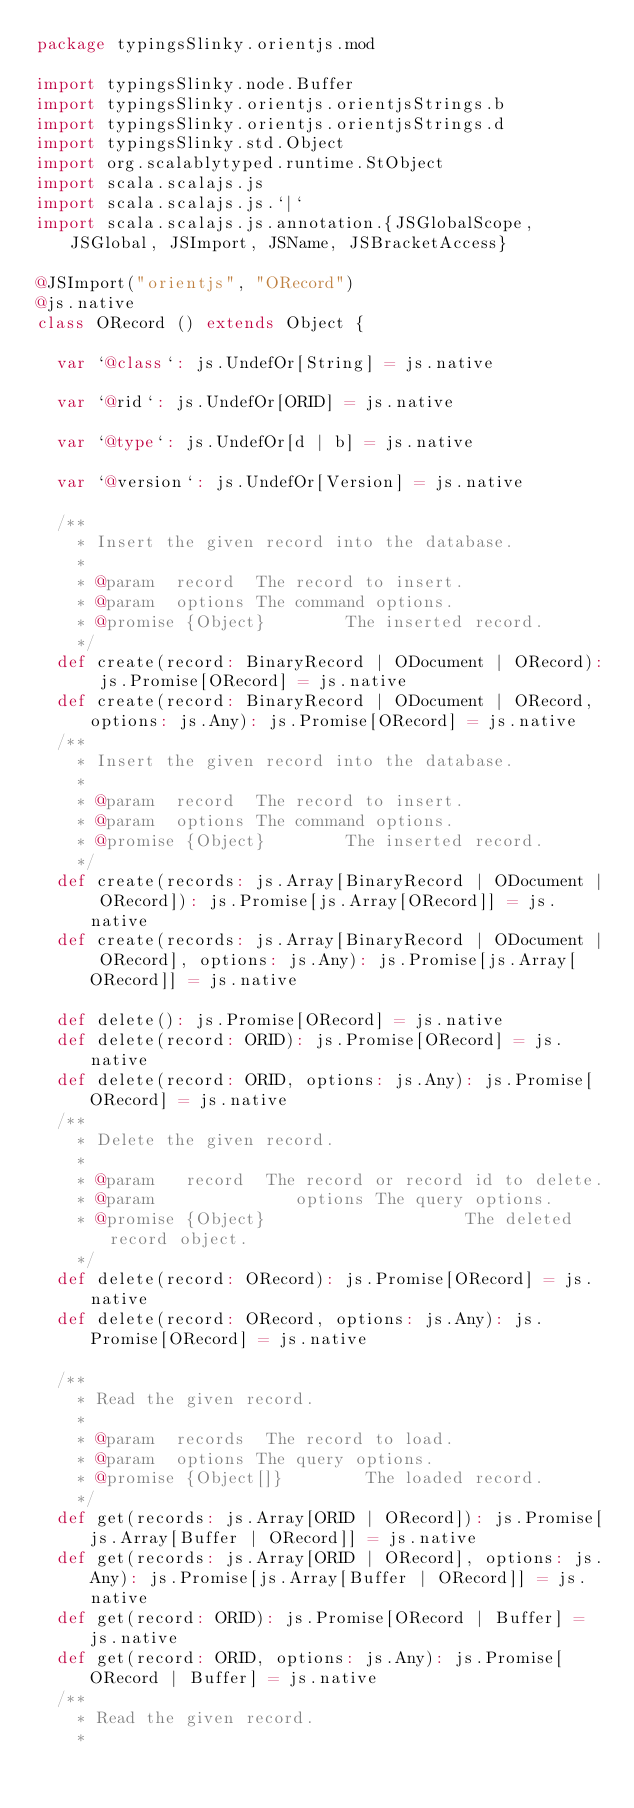<code> <loc_0><loc_0><loc_500><loc_500><_Scala_>package typingsSlinky.orientjs.mod

import typingsSlinky.node.Buffer
import typingsSlinky.orientjs.orientjsStrings.b
import typingsSlinky.orientjs.orientjsStrings.d
import typingsSlinky.std.Object
import org.scalablytyped.runtime.StObject
import scala.scalajs.js
import scala.scalajs.js.`|`
import scala.scalajs.js.annotation.{JSGlobalScope, JSGlobal, JSImport, JSName, JSBracketAccess}

@JSImport("orientjs", "ORecord")
@js.native
class ORecord () extends Object {
  
  var `@class`: js.UndefOr[String] = js.native
  
  var `@rid`: js.UndefOr[ORID] = js.native
  
  var `@type`: js.UndefOr[d | b] = js.native
  
  var `@version`: js.UndefOr[Version] = js.native
  
  /**
    * Insert the given record into the database.
    *
    * @param  record  The record to insert.
    * @param  options The command options.
    * @promise {Object}        The inserted record.
    */
  def create(record: BinaryRecord | ODocument | ORecord): js.Promise[ORecord] = js.native
  def create(record: BinaryRecord | ODocument | ORecord, options: js.Any): js.Promise[ORecord] = js.native
  /**
    * Insert the given record into the database.
    *
    * @param  record  The record to insert.
    * @param  options The command options.
    * @promise {Object}        The inserted record.
    */
  def create(records: js.Array[BinaryRecord | ODocument | ORecord]): js.Promise[js.Array[ORecord]] = js.native
  def create(records: js.Array[BinaryRecord | ODocument | ORecord], options: js.Any): js.Promise[js.Array[ORecord]] = js.native
  
  def delete(): js.Promise[ORecord] = js.native
  def delete(record: ORID): js.Promise[ORecord] = js.native
  def delete(record: ORID, options: js.Any): js.Promise[ORecord] = js.native
  /**
    * Delete the given record.
    *
    * @param   record  The record or record id to delete.
    * @param              options The query options.
    * @promise {Object}                    The deleted record object.
    */
  def delete(record: ORecord): js.Promise[ORecord] = js.native
  def delete(record: ORecord, options: js.Any): js.Promise[ORecord] = js.native
  
  /**
    * Read the given record.
    *
    * @param  records  The record to load.
    * @param  options The query options.
    * @promise {Object[]}        The loaded record.
    */
  def get(records: js.Array[ORID | ORecord]): js.Promise[js.Array[Buffer | ORecord]] = js.native
  def get(records: js.Array[ORID | ORecord], options: js.Any): js.Promise[js.Array[Buffer | ORecord]] = js.native
  def get(record: ORID): js.Promise[ORecord | Buffer] = js.native
  def get(record: ORID, options: js.Any): js.Promise[ORecord | Buffer] = js.native
  /**
    * Read the given record.
    *</code> 